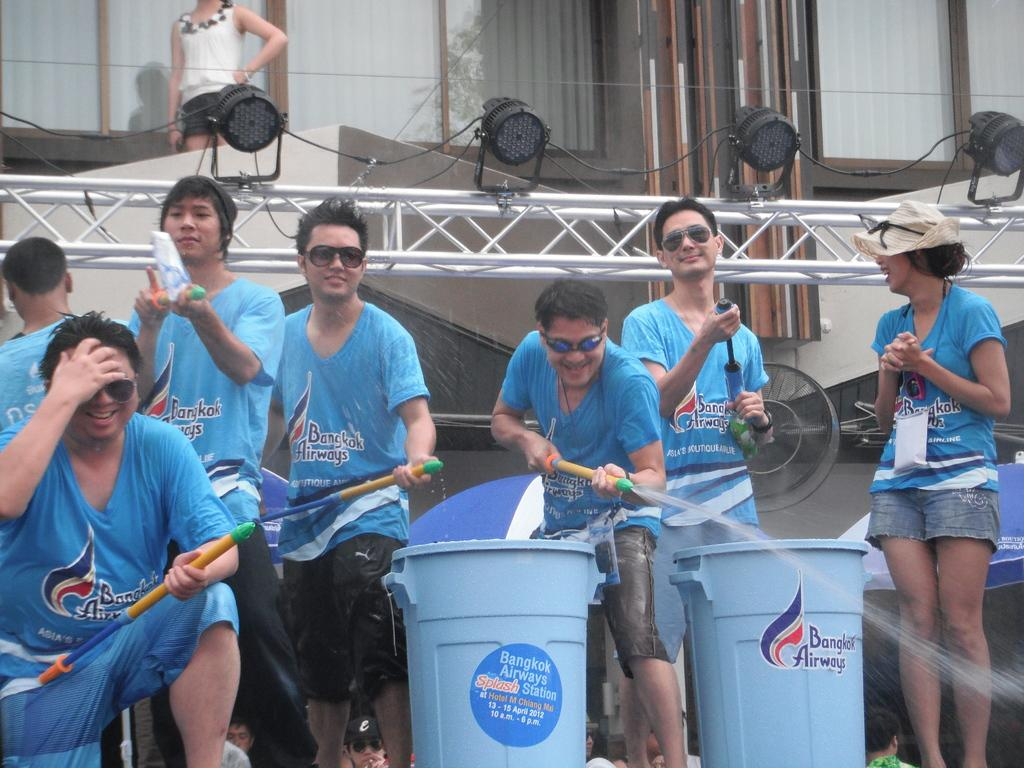Provide a one-sentence caption for the provided image. people with water guns in front of Bangkok Airways garbage bins. 